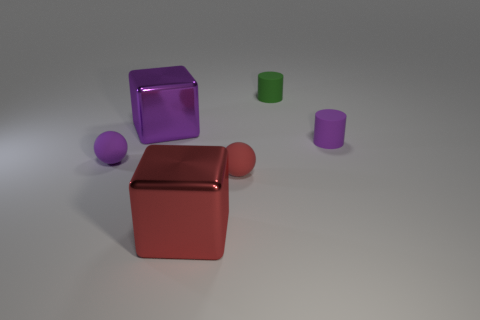Add 3 cylinders. How many objects exist? 9 Subtract 2 cylinders. How many cylinders are left? 0 Subtract all cylinders. How many objects are left? 4 Subtract all purple spheres. How many spheres are left? 1 Subtract all tiny purple metallic blocks. Subtract all small cylinders. How many objects are left? 4 Add 1 large metal things. How many large metal things are left? 3 Add 5 tiny red rubber balls. How many tiny red rubber balls exist? 6 Subtract 0 gray blocks. How many objects are left? 6 Subtract all blue spheres. Subtract all green cylinders. How many spheres are left? 2 Subtract all gray blocks. How many cyan cylinders are left? 0 